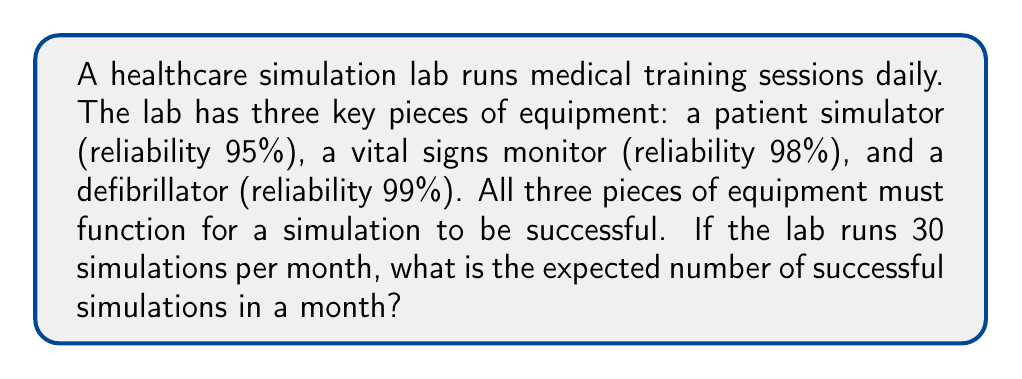What is the answer to this math problem? To solve this problem, we'll follow these steps:

1) First, we need to calculate the probability of all three pieces of equipment working simultaneously for a single simulation:

   $P(\text{all working}) = 0.95 \times 0.98 \times 0.99 = 0.92169$

2) This probability (0.92169) represents the success rate for a single simulation.

3) Now, we can use the concept of expected value. The expected value is calculated by multiplying the number of trials by the probability of success:

   $E(\text{successful simulations}) = n \times p$

   Where:
   $n$ = number of simulations per month
   $p$ = probability of a successful simulation

4) Substituting our values:

   $E(\text{successful simulations}) = 30 \times 0.92169$

5) Calculating:

   $E(\text{successful simulations}) = 27.6507$

Therefore, the expected number of successful simulations in a month is approximately 27.65.
Answer: 27.65 simulations 